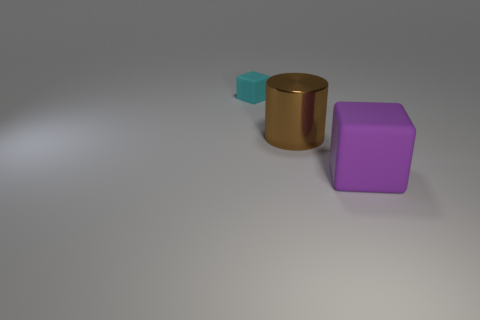How many things are on the right side of the cyan matte cube and behind the big purple matte object?
Your answer should be very brief. 1. The block in front of the small matte object is what color?
Make the answer very short. Purple. There is another cube that is the same material as the purple cube; what is its size?
Your response must be concise. Small. There is a rubber block to the left of the big purple thing; how many purple objects are behind it?
Offer a very short reply. 0. What number of tiny rubber blocks are left of the brown object?
Offer a terse response. 1. There is a matte cube that is behind the big object behind the matte object in front of the cyan thing; what color is it?
Your answer should be compact. Cyan. What is the shape of the rubber thing behind the thing that is in front of the shiny cylinder?
Make the answer very short. Cube. Is there a gray rubber block of the same size as the brown shiny object?
Offer a very short reply. No. What number of big shiny objects have the same shape as the purple rubber object?
Your answer should be compact. 0. Are there the same number of matte blocks left of the small cube and big cylinders to the left of the brown cylinder?
Make the answer very short. Yes. 